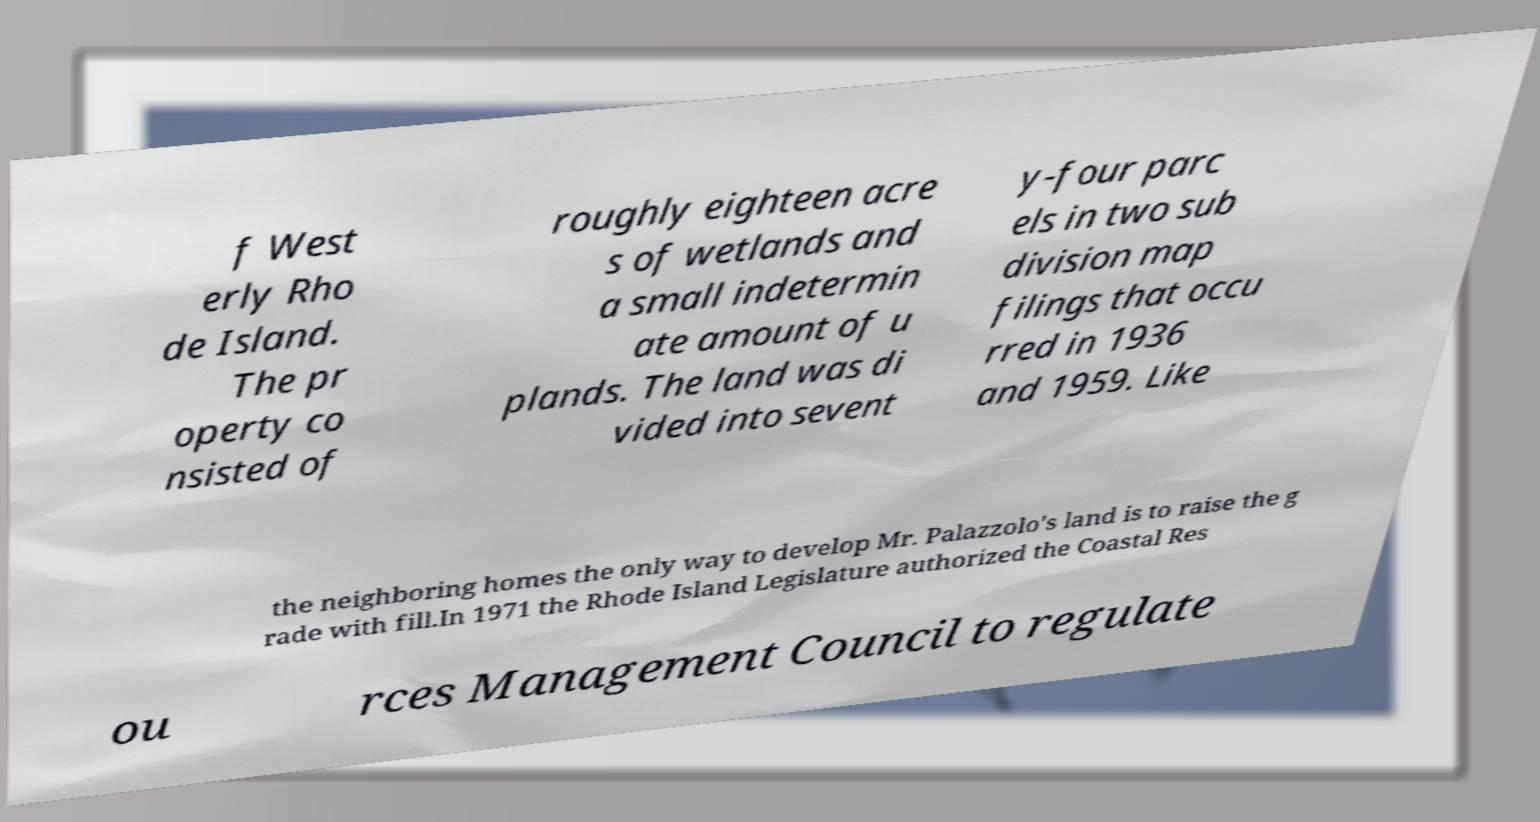Please read and relay the text visible in this image. What does it say? f West erly Rho de Island. The pr operty co nsisted of roughly eighteen acre s of wetlands and a small indetermin ate amount of u plands. The land was di vided into sevent y-four parc els in two sub division map filings that occu rred in 1936 and 1959. Like the neighboring homes the only way to develop Mr. Palazzolo's land is to raise the g rade with fill.In 1971 the Rhode Island Legislature authorized the Coastal Res ou rces Management Council to regulate 